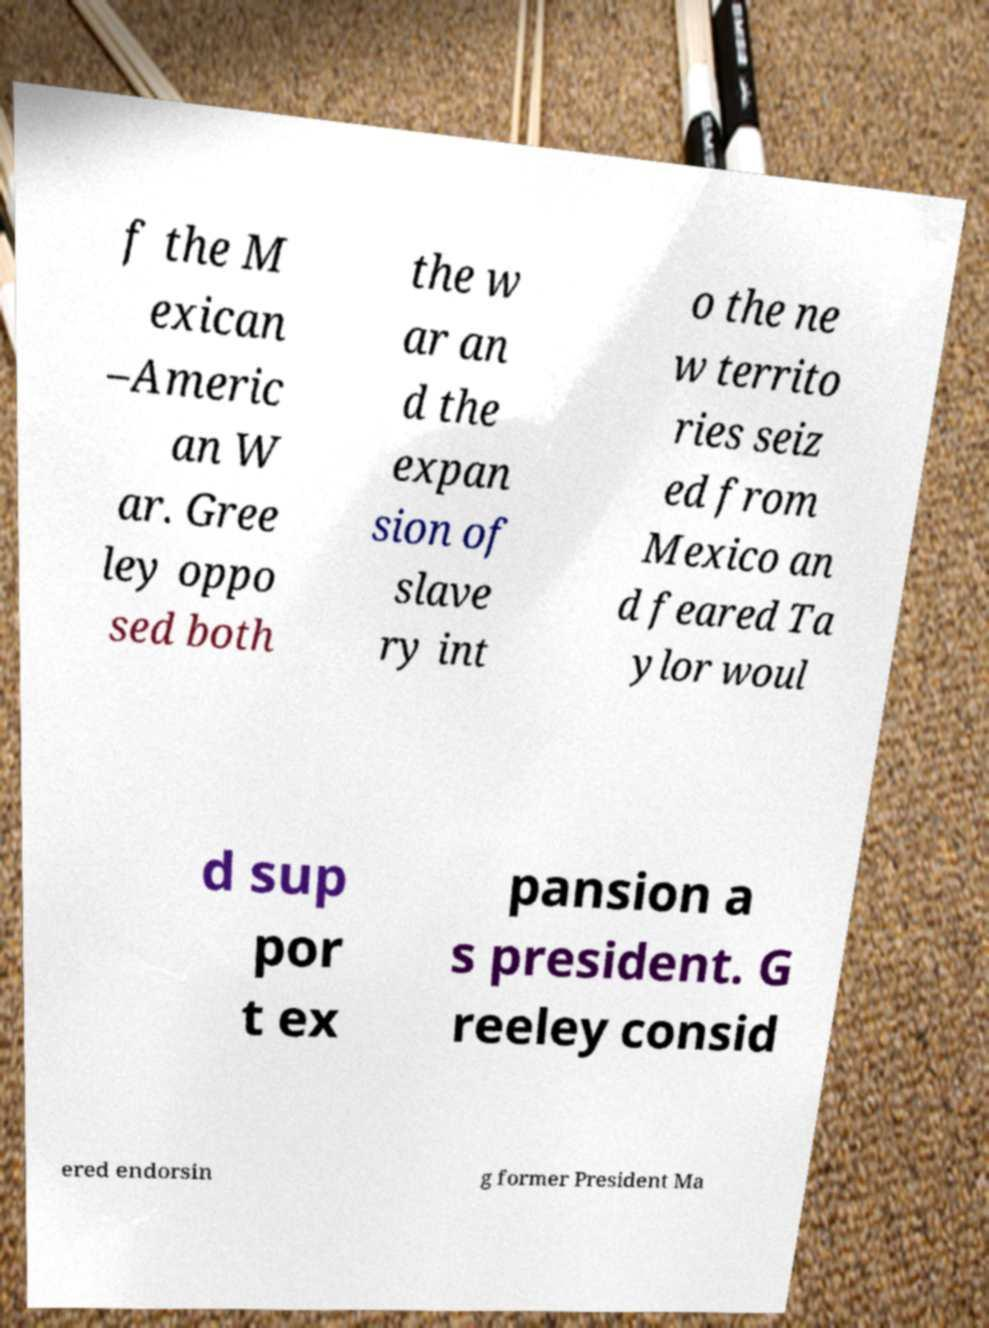What messages or text are displayed in this image? I need them in a readable, typed format. f the M exican –Americ an W ar. Gree ley oppo sed both the w ar an d the expan sion of slave ry int o the ne w territo ries seiz ed from Mexico an d feared Ta ylor woul d sup por t ex pansion a s president. G reeley consid ered endorsin g former President Ma 